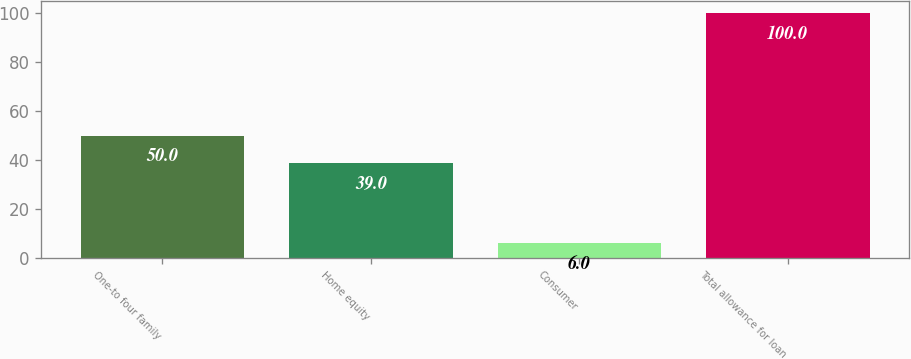Convert chart. <chart><loc_0><loc_0><loc_500><loc_500><bar_chart><fcel>One-to four family<fcel>Home equity<fcel>Consumer<fcel>Total allowance for loan<nl><fcel>50<fcel>39<fcel>6<fcel>100<nl></chart> 